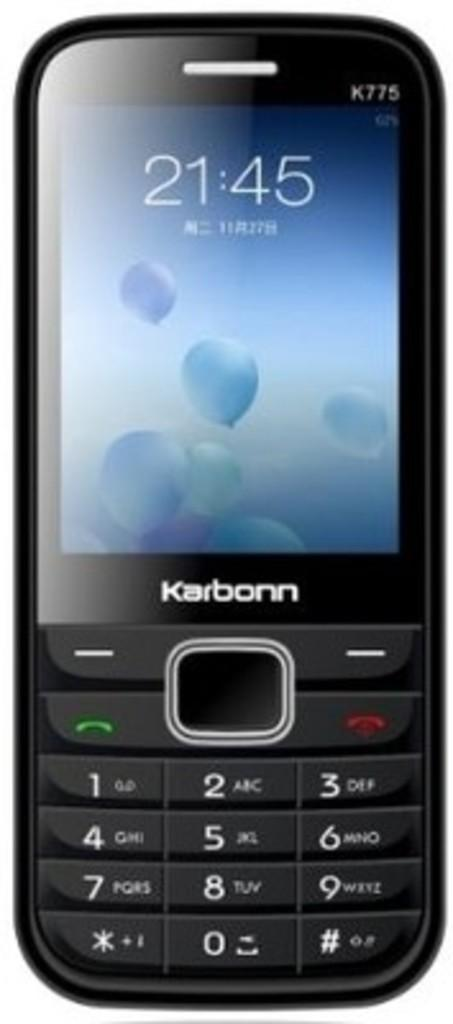<image>
Provide a brief description of the given image. A cell phone displays the brand name Karbonn. 